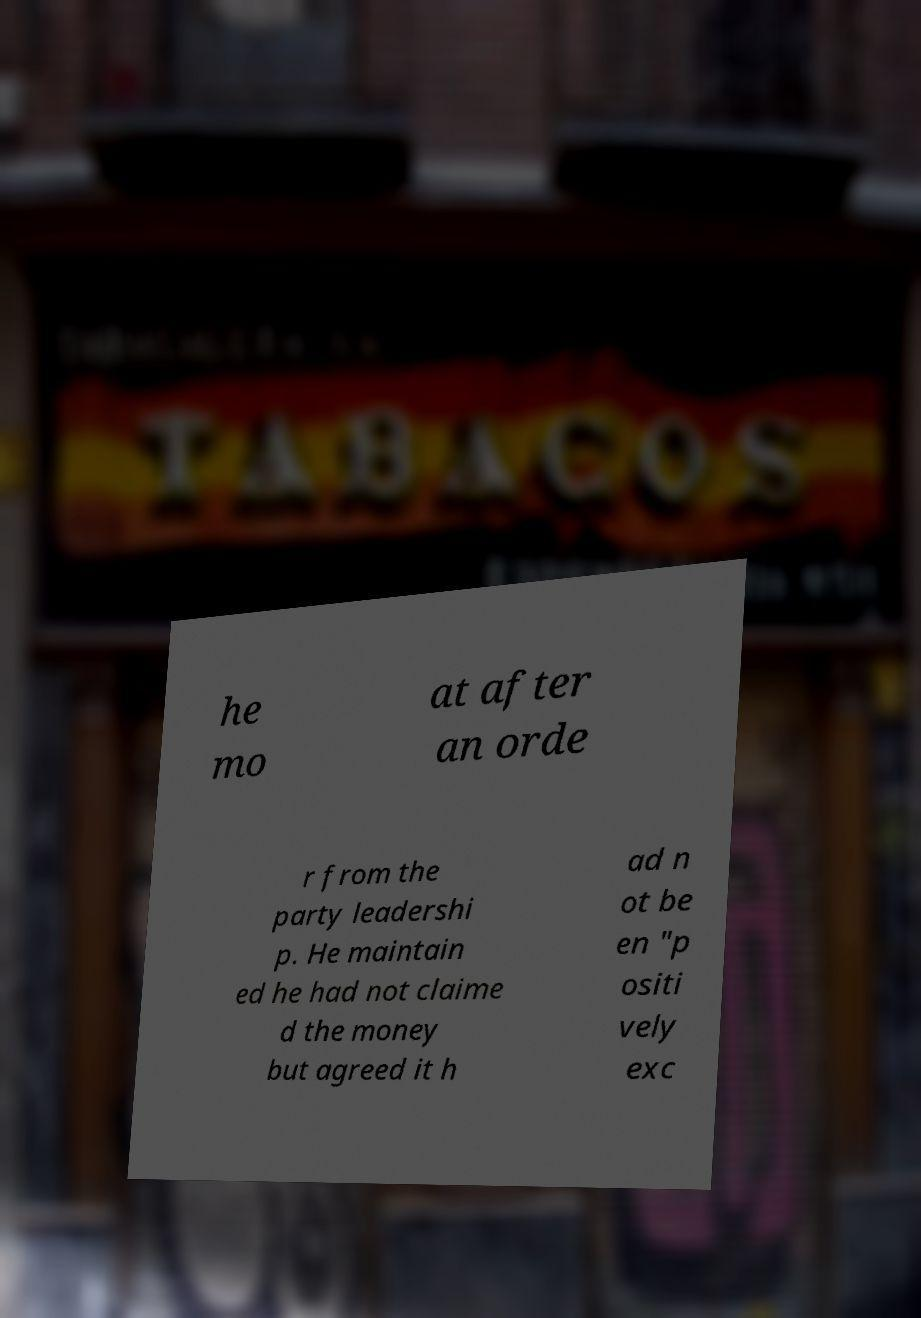I need the written content from this picture converted into text. Can you do that? he mo at after an orde r from the party leadershi p. He maintain ed he had not claime d the money but agreed it h ad n ot be en "p ositi vely exc 